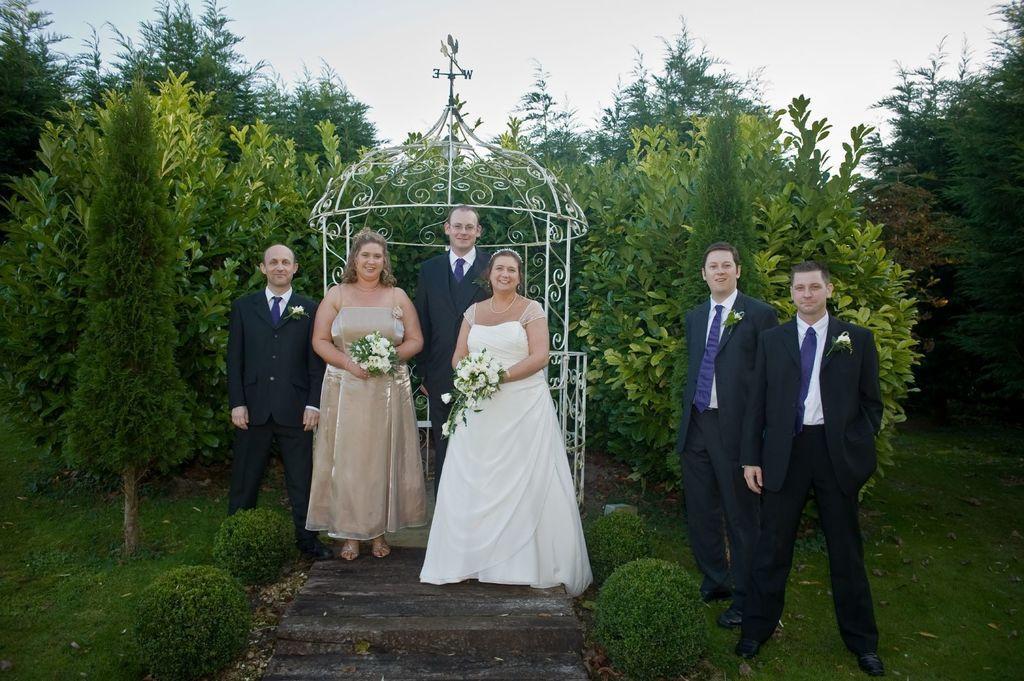Can you describe this image briefly? In the center of the image we can see people standing. The ladies standing in the center are holding bouquets in their hands. In the background there is a shed, trees and sky. 